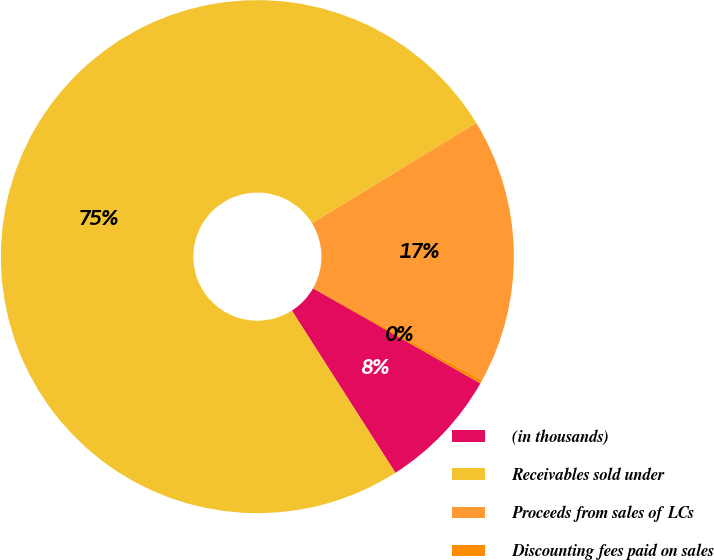Convert chart to OTSL. <chart><loc_0><loc_0><loc_500><loc_500><pie_chart><fcel>(in thousands)<fcel>Receivables sold under<fcel>Proceeds from sales of LCs<fcel>Discounting fees paid on sales<nl><fcel>7.73%<fcel>75.33%<fcel>16.73%<fcel>0.22%<nl></chart> 